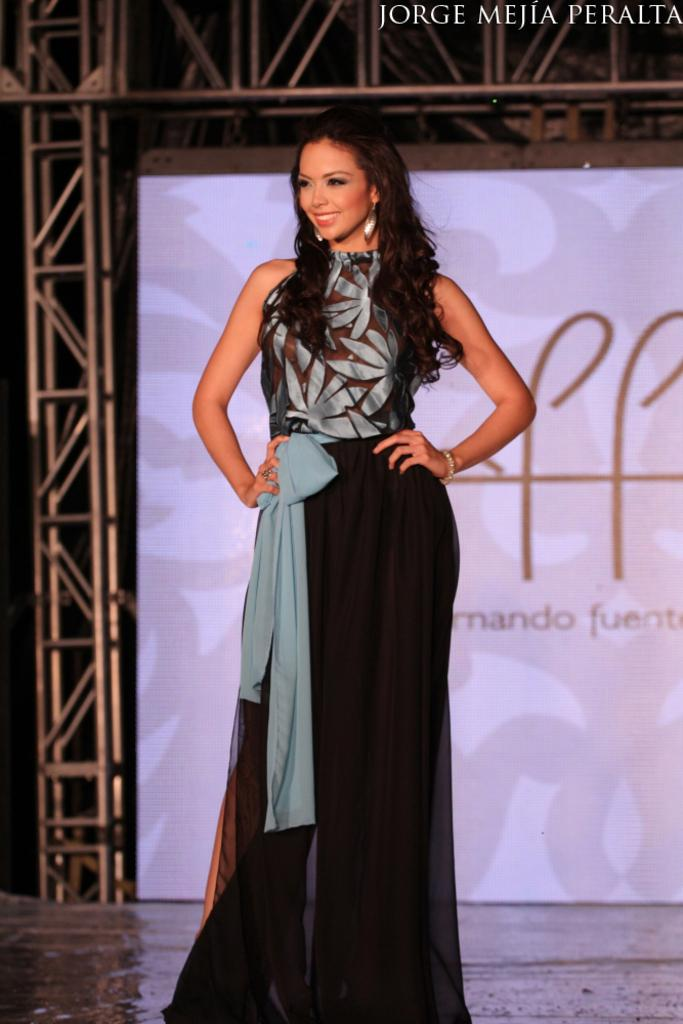What is the woman in the image doing? The woman is standing in the image. What is the woman's facial expression? The woman is smiling. What can be seen in the background of the image? There is a banner with text and metal rods visible in the background. What type of feather is floating near the woman's face in the image? There is no feather present in the image. 